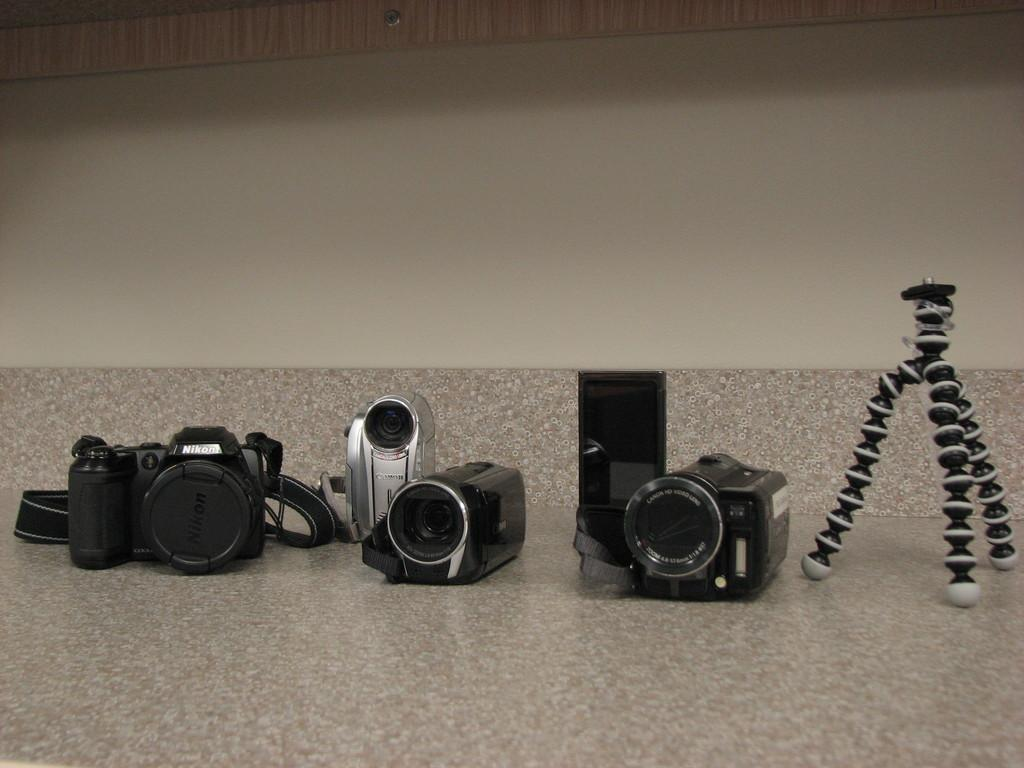What is the main subject of the image? The main subject of the image is many cameras. Can you describe the stand in the image? There is a stand in the image, and it is on the surface. What is visible in the background of the image? There is a wall in the background of the image. What type of steel is used to construct the cameras in the image? There is no information about the type of steel used in the cameras in the image. Can you see a hammer being used with the cameras in the image? There is no hammer present in the image. Is there any salt visible on the stand in the image? There is no salt present in the image. 